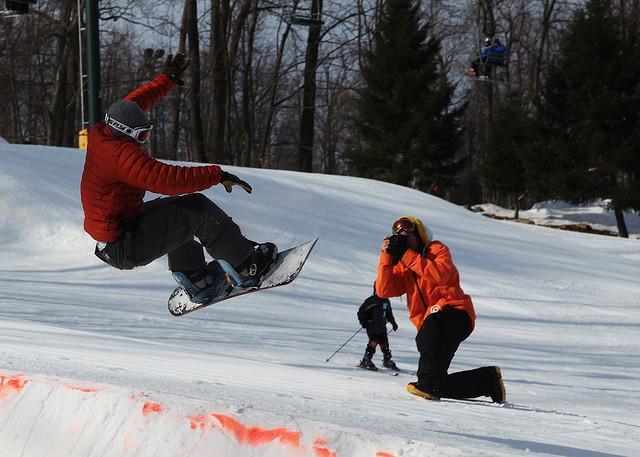How many people are on boards?
Give a very brief answer. 1. How many people are in the picture?
Give a very brief answer. 2. 